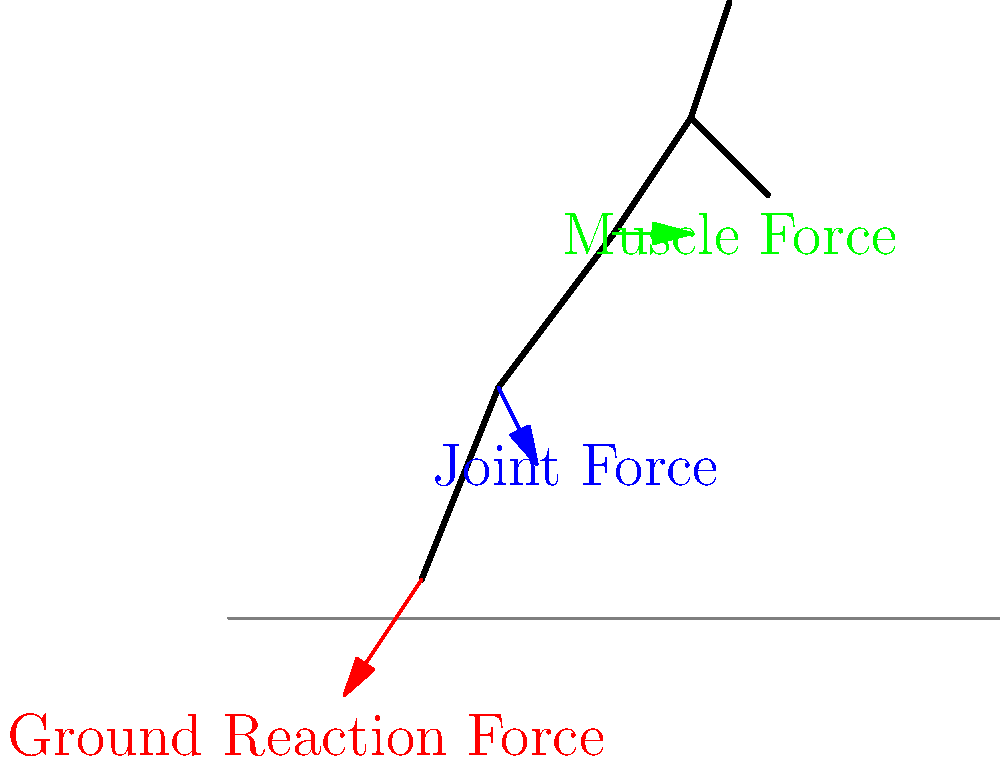As a tech journalist covering server and storage technologies, you're tasked with explaining the biomechanics of running to your readers using a data storage analogy. Analyze the force vector diagram of a runner's stride. Which force is most analogous to the read/write operations in a solid-state drive (SSD), and why? To answer this question, let's break down the forces acting on a runner and compare them to SSD operations:

1. Ground Reaction Force (GRF):
   - Acts upward from the ground on the foot
   - Relatively slow and cyclical (occurs once per stride)
   - Analogous to bulk data transfers in storage systems

2. Joint Force:
   - Acts within the joints (e.g., knee, ankle)
   - Occurs continuously throughout the stride
   - Analogous to background processes in a storage system

3. Muscle Force:
   - Generated by muscles to produce movement
   - Rapid, precise, and can change quickly
   - Most analogous to SSD read/write operations

The Muscle Force is most similar to SSD read/write operations because:

a) Speed: Muscle contractions can occur rapidly, similar to the quick read/write speeds of SSDs.
b) Precision: Muscles can make fine adjustments, just as SSDs can access specific data blocks precisely.
c) Adaptability: Muscle force can change quickly based on need, similar to how SSDs can handle random access requests efficiently.
d) Energy efficiency: Both muscles and SSDs are designed for efficient energy use in their respective systems.

In contrast, the Ground Reaction Force is more like bulk data transfers (slower, more cyclical), and the Joint Force is more like background processes (continuous, supportive operations).
Answer: Muscle Force 